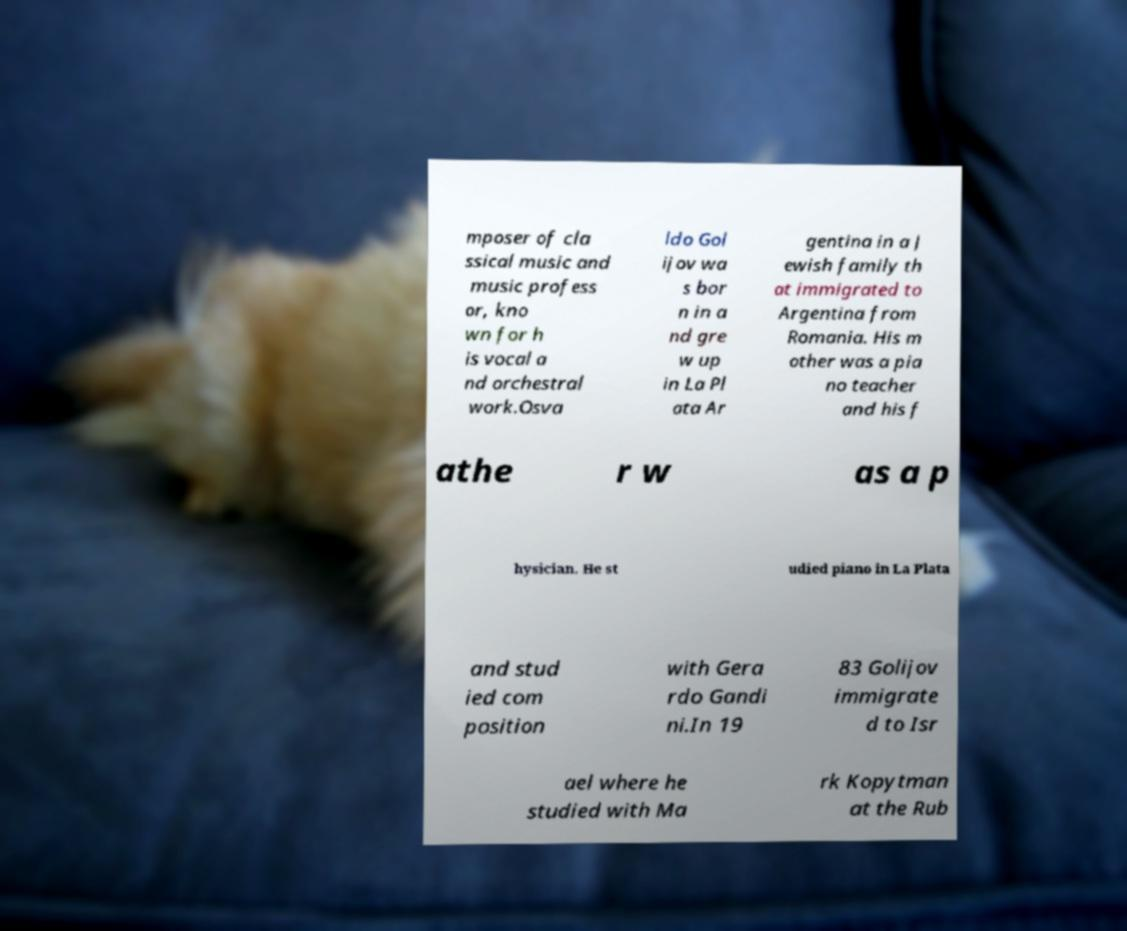I need the written content from this picture converted into text. Can you do that? mposer of cla ssical music and music profess or, kno wn for h is vocal a nd orchestral work.Osva ldo Gol ijov wa s bor n in a nd gre w up in La Pl ata Ar gentina in a J ewish family th at immigrated to Argentina from Romania. His m other was a pia no teacher and his f athe r w as a p hysician. He st udied piano in La Plata and stud ied com position with Gera rdo Gandi ni.In 19 83 Golijov immigrate d to Isr ael where he studied with Ma rk Kopytman at the Rub 